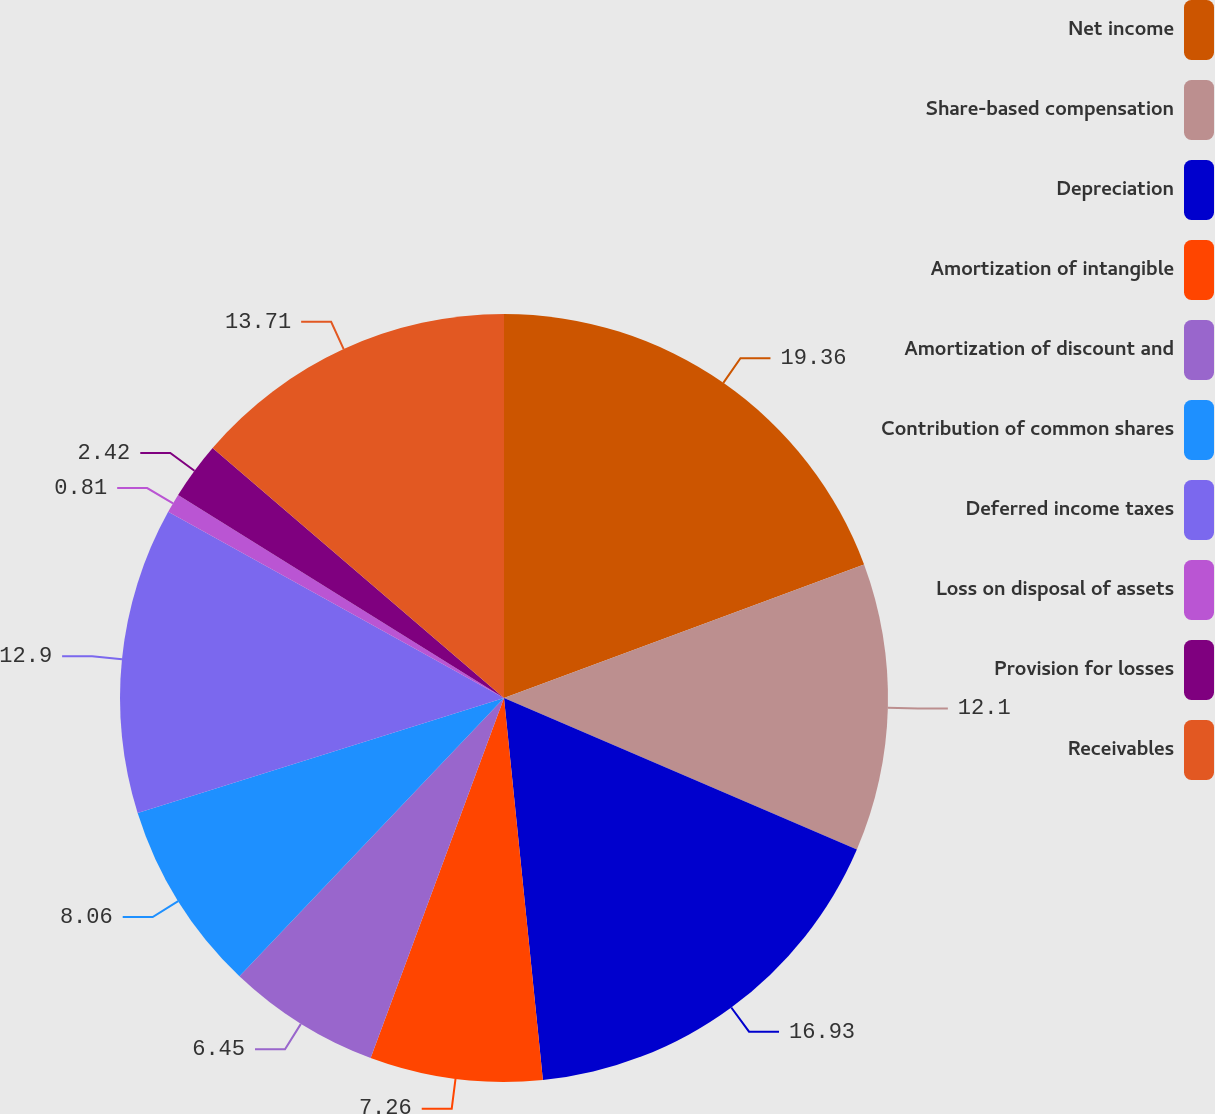Convert chart. <chart><loc_0><loc_0><loc_500><loc_500><pie_chart><fcel>Net income<fcel>Share-based compensation<fcel>Depreciation<fcel>Amortization of intangible<fcel>Amortization of discount and<fcel>Contribution of common shares<fcel>Deferred income taxes<fcel>Loss on disposal of assets<fcel>Provision for losses<fcel>Receivables<nl><fcel>19.35%<fcel>12.1%<fcel>16.93%<fcel>7.26%<fcel>6.45%<fcel>8.06%<fcel>12.9%<fcel>0.81%<fcel>2.42%<fcel>13.71%<nl></chart> 